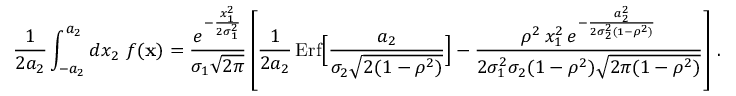Convert formula to latex. <formula><loc_0><loc_0><loc_500><loc_500>{ \frac { 1 } { 2 a _ { 2 } } } \int _ { - a _ { 2 } } ^ { a _ { 2 } } d x _ { 2 } \ f ( { x } ) = { \frac { e ^ { - { \frac { x _ { 1 } ^ { 2 } } { 2 \sigma _ { 1 } ^ { 2 } } } } } { \sigma _ { 1 } \sqrt { 2 \pi } } } \left [ { \frac { 1 } { 2 a _ { 2 } } } \, E r f \left [ { \frac { a _ { 2 } } { \sigma _ { 2 } \sqrt { 2 ( 1 - \rho ^ { 2 } ) } } } \right ] - { \frac { \rho ^ { 2 } \, x _ { 1 } ^ { 2 } \, e ^ { - { \frac { a _ { 2 } ^ { 2 } } { 2 \sigma _ { 2 } ^ { 2 } ( 1 - \rho ^ { 2 } ) } } } } { 2 \sigma _ { 1 } ^ { 2 } \sigma _ { 2 } ( 1 - \rho ^ { 2 } ) \sqrt { 2 \pi ( 1 - \rho ^ { 2 } ) } } } \right ] \, .</formula> 